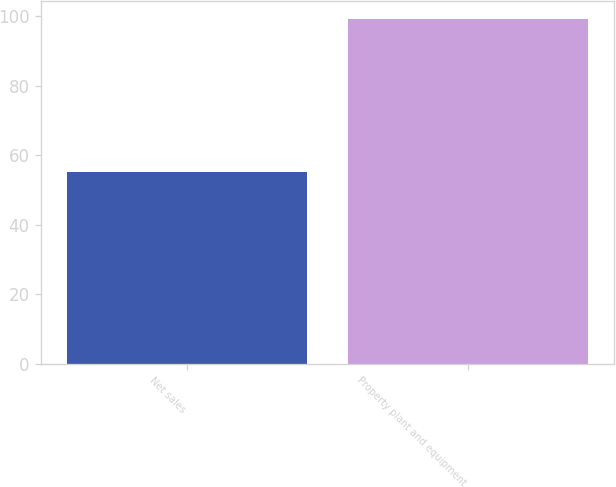<chart> <loc_0><loc_0><loc_500><loc_500><bar_chart><fcel>Net sales<fcel>Property plant and equipment<nl><fcel>55.2<fcel>99.3<nl></chart> 